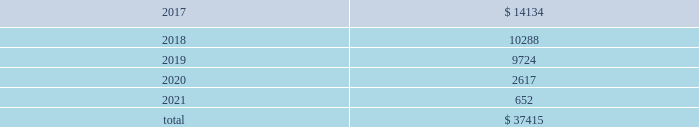Table of contents 17 .
Unconditional purchase obligations the company has entered into various unconditional purchase obligations which primarily include software licenses and long- term purchase contracts for network , communication and office maintenance services .
The company expended $ 7.2 million , $ 5.3 million and $ 2.9 million related to unconditional purchase obligations that existed as of the beginning of each year for the years ended december 31 , 2016 , 2015 and 2014 , respectively .
Future expenditures under unconditional purchase obligations in effect as of december 31 , 2016 are as follows : ( in thousands ) .
18 .
Restructuring during the fourth quarter of 2016 , the company initiated workforce realignment activities .
The company incurred $ 3.4 million in restructuring charges , or $ 2.4 million net of tax , during the year ended december 31 , 2016 .
The company expects to incur additional charges of $ 10 million - $ 15 million , or $ 7 million - $ 10 million net of tax , primarily during the first quarter of 2017 .
19 .
Employment-related settlement on february 15 , 2017 , the company entered into an employment-related settlement agreement .
In connection with the settlement agreement , the company will make a lump-sum payment of $ 4.7 million .
The charges related to this agreement are included in selling , general and administrative expense in the 2016 consolidated statement of income .
As part of the settlement agreement , all the claims initiated against the company will be withdrawn and a general release of all claims in favor of the company and all of its related entities was executed .
20 .
Contingencies and commitments the company is subject to various investigations , claims and legal proceedings that arise in the ordinary course of business , including commercial disputes , labor and employment matters , tax audits , alleged infringement of intellectual property rights and other matters .
In the opinion of the company , the resolution of pending matters is not expected to have a material adverse effect on the company's consolidated results of operations , cash flows or financial position .
However , each of these matters is subject to various uncertainties and it is possible that an unfavorable resolution of one or more of these proceedings could materially affect the company's results of operations , cash flows or financial position .
An indian subsidiary of the company has several service tax audits pending that have resulted in formal inquiries being received on transactions through mid-2012 .
The company could incur tax charges and related liabilities , including those related to the service tax audit case , of approximately $ 7 million .
The service tax issues raised in the company 2019s notices and inquiries are very similar to the case , m/s microsoft corporation ( i ) ( p ) ltd .
Vs commissioner of service tax , new delhi , wherein the delhi customs , excise and service tax appellate tribunal ( cestat ) has passed a favorable ruling to microsoft .
The company can provide no assurances on whether the microsoft case 2019s favorable ruling will be challenged in higher courts or on the impact that the present microsoft case 2019s decision will have on the company 2019s cases .
The company is uncertain as to when these service tax matters will be concluded .
A french subsidiary of the company received notice that the french taxing authority rejected the company's 2012 research and development credit .
The company has contested the decision .
However , if the company does not receive a favorable outcome , it could incur charges of approximately $ 0.8 million .
In addition , an unfavorable outcome could result in the authorities reviewing or rejecting $ 3.8 million of similar research and development credits for 2013 through the current year that are currently reflected as an asset .
The company can provide no assurances on the timing or outcome of this matter. .
As of december 31 , 2016 what was the percent of the future expenditures under unconditional purchase obligations that was due in 2018? 
Computations: (10288 / 37415)
Answer: 0.27497. 